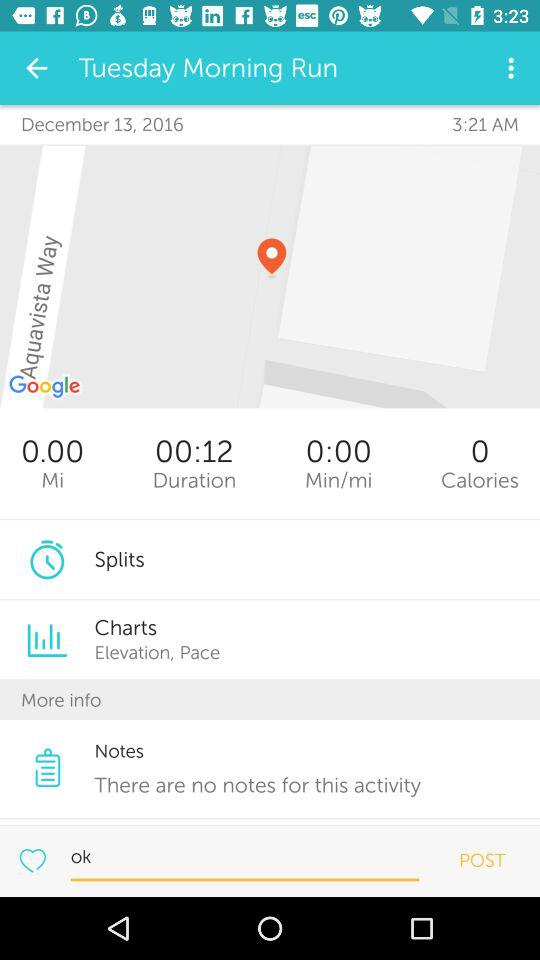At what time is the morning run scheduled? The morning run is scheduled for 3:21 AM. 